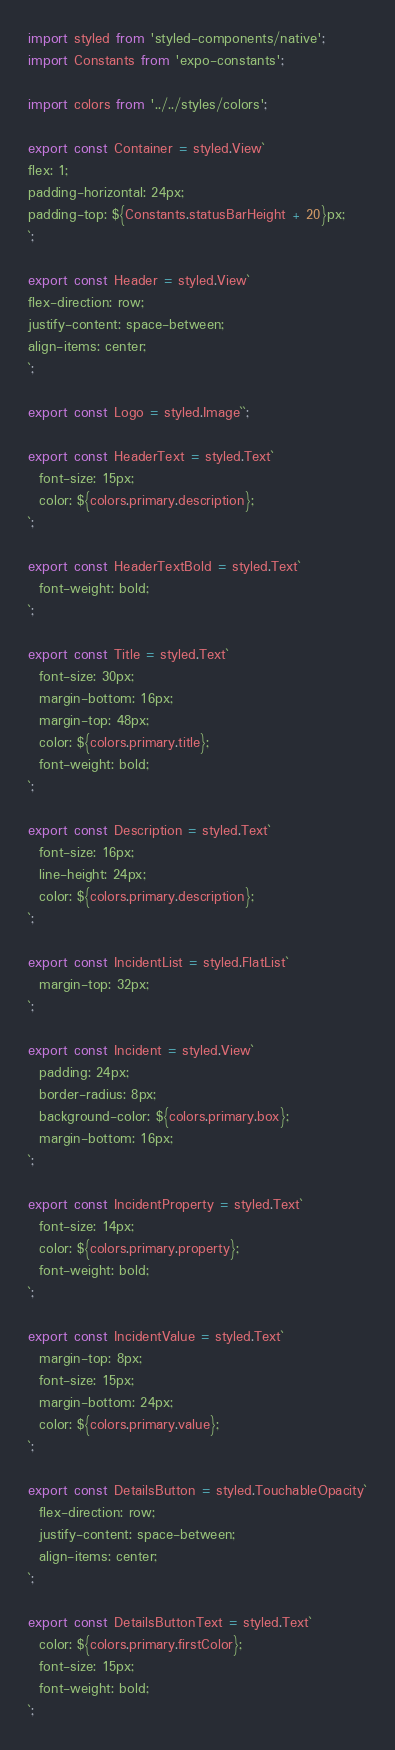Convert code to text. <code><loc_0><loc_0><loc_500><loc_500><_JavaScript_>import styled from 'styled-components/native';
import Constants from 'expo-constants';

import colors from '../../styles/colors';

export const Container = styled.View`
flex: 1;
padding-horizontal: 24px;
padding-top: ${Constants.statusBarHeight + 20}px;
`;

export const Header = styled.View`
flex-direction: row;
justify-content: space-between;
align-items: center;
`;

export const Logo = styled.Image``;

export const HeaderText = styled.Text`
  font-size: 15px;
  color: ${colors.primary.description};
`;

export const HeaderTextBold = styled.Text`
  font-weight: bold;
`;

export const Title = styled.Text`
  font-size: 30px;
  margin-bottom: 16px;
  margin-top: 48px;
  color: ${colors.primary.title};
  font-weight: bold;
`;

export const Description = styled.Text`
  font-size: 16px;
  line-height: 24px;
  color: ${colors.primary.description};
`;

export const IncidentList = styled.FlatList`
  margin-top: 32px;
`;

export const Incident = styled.View`
  padding: 24px;
  border-radius: 8px;
  background-color: ${colors.primary.box};
  margin-bottom: 16px;
`;

export const IncidentProperty = styled.Text`
  font-size: 14px;
  color: ${colors.primary.property};
  font-weight: bold;
`;

export const IncidentValue = styled.Text`
  margin-top: 8px;
  font-size: 15px;
  margin-bottom: 24px;
  color: ${colors.primary.value};
`;

export const DetailsButton = styled.TouchableOpacity`
  flex-direction: row;
  justify-content: space-between;
  align-items: center;
`;

export const DetailsButtonText = styled.Text`
  color: ${colors.primary.firstColor};
  font-size: 15px;
  font-weight: bold;
`;
</code> 